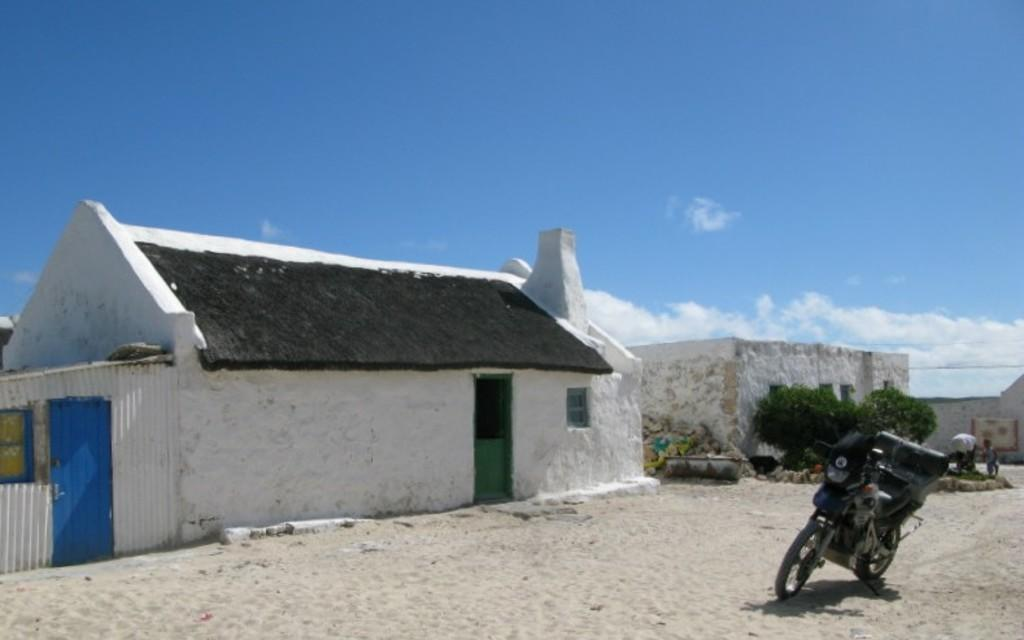What is the main subject in the center of the image? There are houses in the center of the image. What is located in front of the houses? There is a road in front of the houses. What can be seen on the road? There is a bike on the road. What is visible in the background of the image? The sky is visible in the background of the image. Where is the church located in the image? There is no church present in the image. Can you see any roses growing near the houses? There is no mention of roses in the image; only houses, a road, a bike, and the sky are visible. 